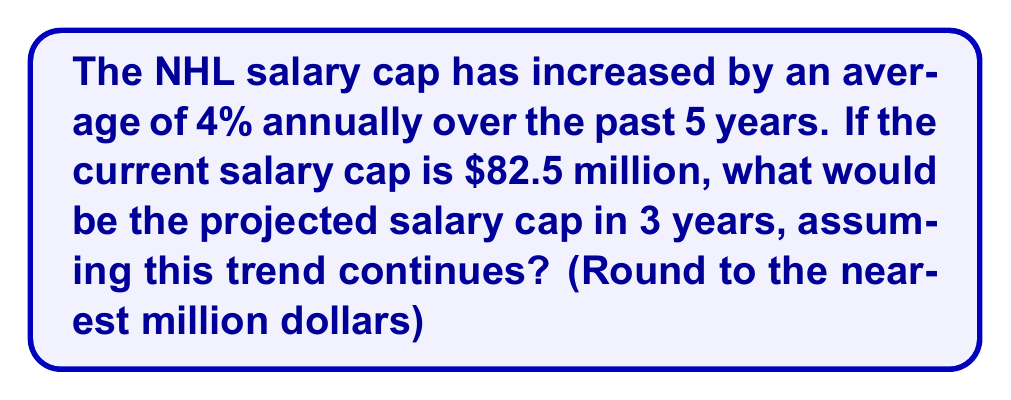Provide a solution to this math problem. Let's approach this step-by-step:

1) We start with the current salary cap of $82.5 million.

2) The salary cap increases by 4% each year. This means we need to multiply the current cap by 1.04 for each year:

   Year 1: $82.5 million × 1.04 = $85.8 million
   Year 2: $85.8 million × 1.04 = $89.232 million
   Year 3: $89.232 million × 1.04 = $92.80128 million

3) We can express this mathematically as:

   $82.5 million × (1.04)^3 = $92.80128 million

4) Alternatively, we could use the compound interest formula:

   $A = P(1 + r)^n$

   Where:
   $A$ is the final amount
   $P$ is the principal (initial amount)
   $r$ is the annual rate (as a decimal)
   $n$ is the number of years

   $A = 82.5(1 + 0.04)^3 = 82.5(1.04)^3 = $92.80128 million

5) Rounding to the nearest million:

   $92.80128 million ≈ $93 million

Therefore, based on the given trend, the projected NHL salary cap in 3 years would be approximately $93 million.
Answer: $93 million 